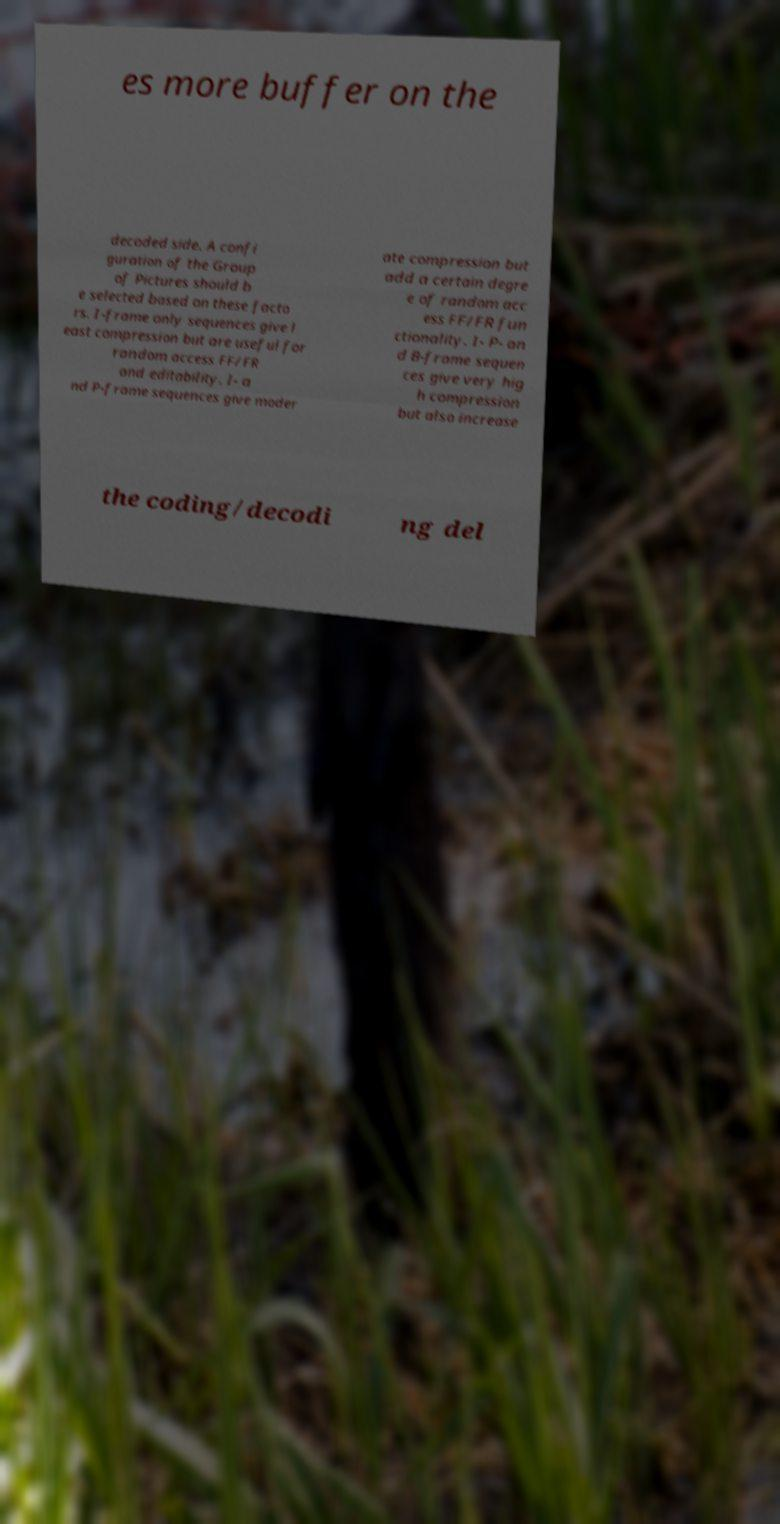Could you extract and type out the text from this image? es more buffer on the decoded side. A confi guration of the Group of Pictures should b e selected based on these facto rs. I-frame only sequences give l east compression but are useful for random access FF/FR and editability. I- a nd P-frame sequences give moder ate compression but add a certain degre e of random acc ess FF/FR fun ctionality. I- P- an d B-frame sequen ces give very hig h compression but also increase the coding/decodi ng del 